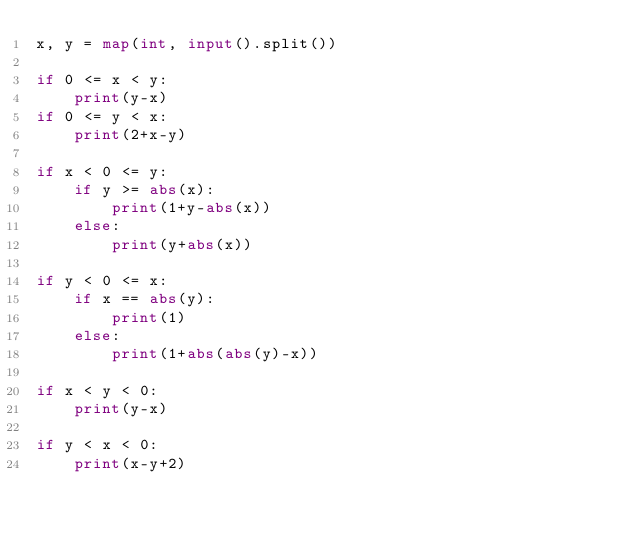Convert code to text. <code><loc_0><loc_0><loc_500><loc_500><_Python_>x, y = map(int, input().split())

if 0 <= x < y:
    print(y-x)
if 0 <= y < x:
    print(2+x-y)

if x < 0 <= y:
    if y >= abs(x):
        print(1+y-abs(x))
    else:
        print(y+abs(x))

if y < 0 <= x:
    if x == abs(y):
        print(1)
    else:
        print(1+abs(abs(y)-x))

if x < y < 0:
    print(y-x)

if y < x < 0:
    print(x-y+2)
</code> 